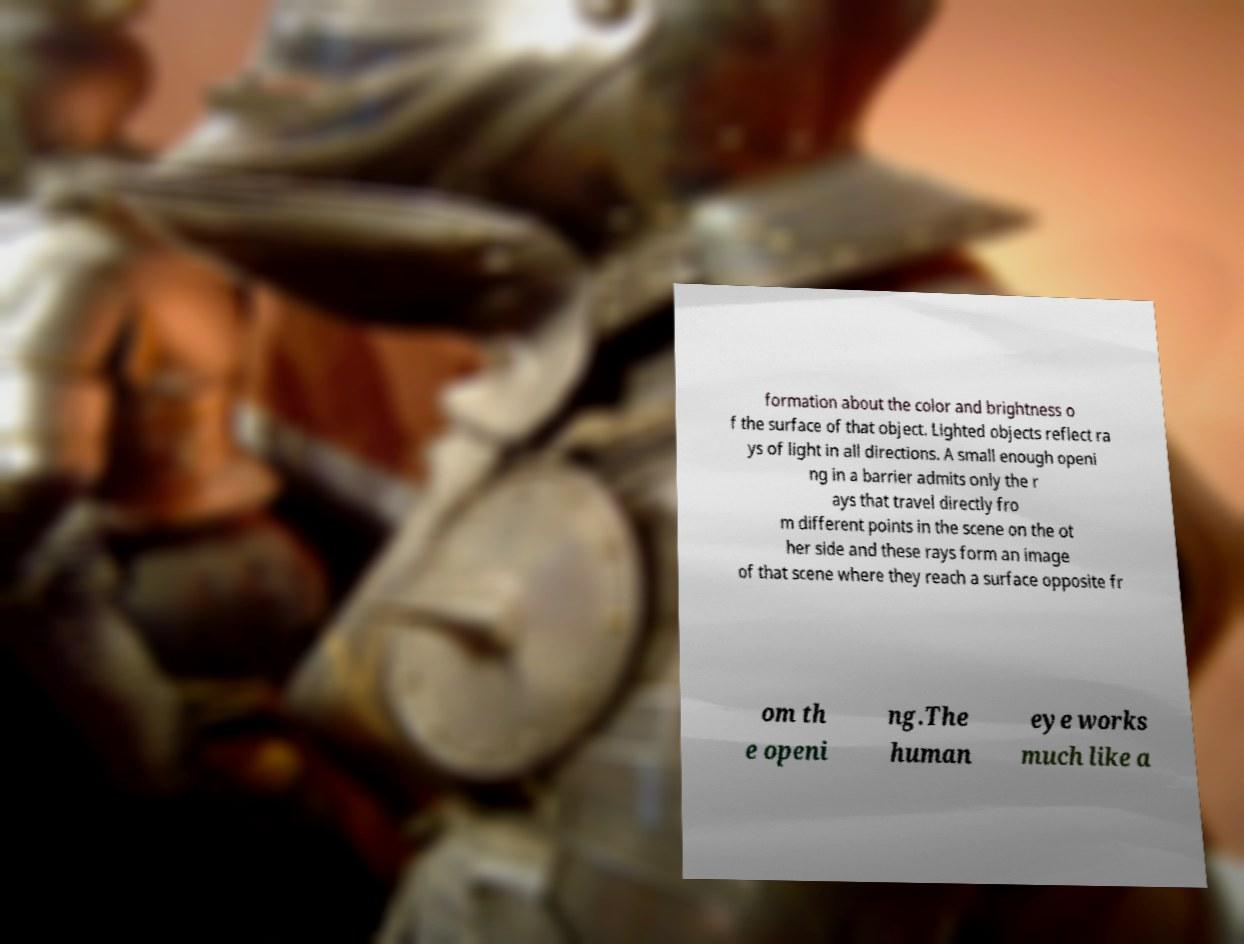Can you read and provide the text displayed in the image?This photo seems to have some interesting text. Can you extract and type it out for me? formation about the color and brightness o f the surface of that object. Lighted objects reflect ra ys of light in all directions. A small enough openi ng in a barrier admits only the r ays that travel directly fro m different points in the scene on the ot her side and these rays form an image of that scene where they reach a surface opposite fr om th e openi ng.The human eye works much like a 